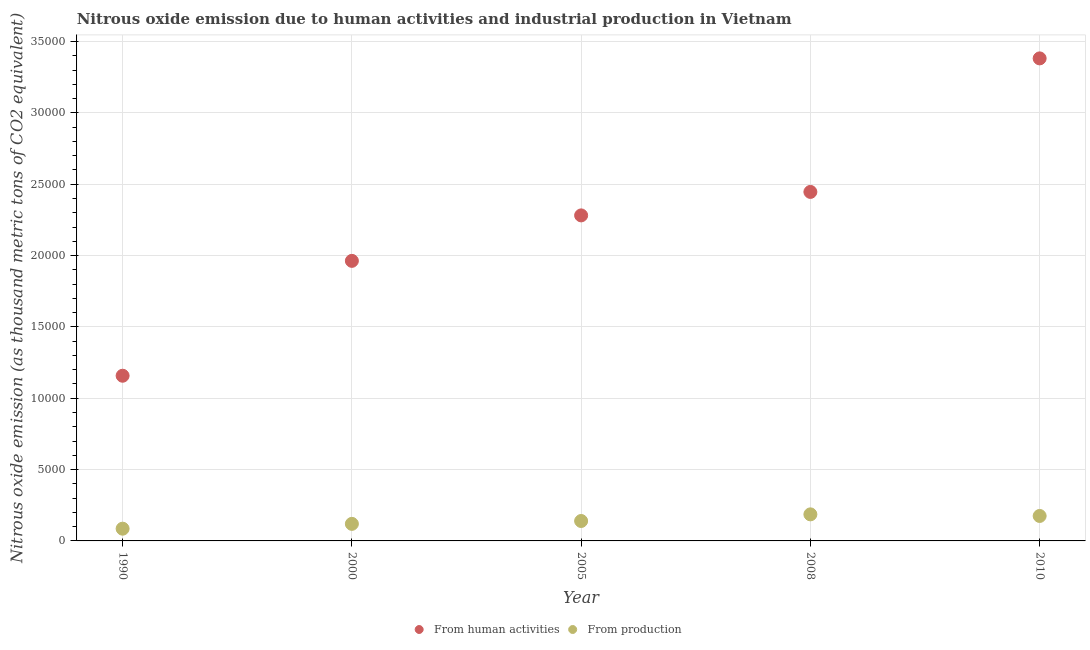How many different coloured dotlines are there?
Keep it short and to the point. 2. What is the amount of emissions generated from industries in 2005?
Provide a short and direct response. 1396.4. Across all years, what is the maximum amount of emissions generated from industries?
Make the answer very short. 1861.6. Across all years, what is the minimum amount of emissions from human activities?
Provide a short and direct response. 1.16e+04. What is the total amount of emissions generated from industries in the graph?
Ensure brevity in your answer.  7060.1. What is the difference between the amount of emissions generated from industries in 1990 and that in 2008?
Ensure brevity in your answer.  -1004.2. What is the difference between the amount of emissions generated from industries in 2000 and the amount of emissions from human activities in 2005?
Give a very brief answer. -2.16e+04. What is the average amount of emissions generated from industries per year?
Offer a very short reply. 1412.02. In the year 2000, what is the difference between the amount of emissions from human activities and amount of emissions generated from industries?
Give a very brief answer. 1.84e+04. What is the ratio of the amount of emissions generated from industries in 1990 to that in 2010?
Ensure brevity in your answer.  0.49. Is the amount of emissions from human activities in 2005 less than that in 2010?
Ensure brevity in your answer.  Yes. Is the difference between the amount of emissions generated from industries in 2000 and 2010 greater than the difference between the amount of emissions from human activities in 2000 and 2010?
Your answer should be very brief. Yes. What is the difference between the highest and the second highest amount of emissions from human activities?
Keep it short and to the point. 9358.4. What is the difference between the highest and the lowest amount of emissions from human activities?
Provide a succinct answer. 2.22e+04. Does the amount of emissions from human activities monotonically increase over the years?
Give a very brief answer. Yes. Is the amount of emissions from human activities strictly greater than the amount of emissions generated from industries over the years?
Ensure brevity in your answer.  Yes. How many years are there in the graph?
Provide a short and direct response. 5. Are the values on the major ticks of Y-axis written in scientific E-notation?
Offer a very short reply. No. Does the graph contain any zero values?
Keep it short and to the point. No. Where does the legend appear in the graph?
Make the answer very short. Bottom center. How are the legend labels stacked?
Offer a terse response. Horizontal. What is the title of the graph?
Your answer should be compact. Nitrous oxide emission due to human activities and industrial production in Vietnam. Does "DAC donors" appear as one of the legend labels in the graph?
Ensure brevity in your answer.  No. What is the label or title of the X-axis?
Make the answer very short. Year. What is the label or title of the Y-axis?
Your answer should be compact. Nitrous oxide emission (as thousand metric tons of CO2 equivalent). What is the Nitrous oxide emission (as thousand metric tons of CO2 equivalent) in From human activities in 1990?
Ensure brevity in your answer.  1.16e+04. What is the Nitrous oxide emission (as thousand metric tons of CO2 equivalent) of From production in 1990?
Keep it short and to the point. 857.4. What is the Nitrous oxide emission (as thousand metric tons of CO2 equivalent) in From human activities in 2000?
Provide a short and direct response. 1.96e+04. What is the Nitrous oxide emission (as thousand metric tons of CO2 equivalent) in From production in 2000?
Offer a very short reply. 1195.6. What is the Nitrous oxide emission (as thousand metric tons of CO2 equivalent) of From human activities in 2005?
Keep it short and to the point. 2.28e+04. What is the Nitrous oxide emission (as thousand metric tons of CO2 equivalent) of From production in 2005?
Provide a succinct answer. 1396.4. What is the Nitrous oxide emission (as thousand metric tons of CO2 equivalent) of From human activities in 2008?
Your answer should be compact. 2.45e+04. What is the Nitrous oxide emission (as thousand metric tons of CO2 equivalent) of From production in 2008?
Ensure brevity in your answer.  1861.6. What is the Nitrous oxide emission (as thousand metric tons of CO2 equivalent) in From human activities in 2010?
Keep it short and to the point. 3.38e+04. What is the Nitrous oxide emission (as thousand metric tons of CO2 equivalent) of From production in 2010?
Make the answer very short. 1749.1. Across all years, what is the maximum Nitrous oxide emission (as thousand metric tons of CO2 equivalent) in From human activities?
Your answer should be very brief. 3.38e+04. Across all years, what is the maximum Nitrous oxide emission (as thousand metric tons of CO2 equivalent) of From production?
Provide a short and direct response. 1861.6. Across all years, what is the minimum Nitrous oxide emission (as thousand metric tons of CO2 equivalent) in From human activities?
Offer a very short reply. 1.16e+04. Across all years, what is the minimum Nitrous oxide emission (as thousand metric tons of CO2 equivalent) in From production?
Ensure brevity in your answer.  857.4. What is the total Nitrous oxide emission (as thousand metric tons of CO2 equivalent) in From human activities in the graph?
Keep it short and to the point. 1.12e+05. What is the total Nitrous oxide emission (as thousand metric tons of CO2 equivalent) in From production in the graph?
Offer a terse response. 7060.1. What is the difference between the Nitrous oxide emission (as thousand metric tons of CO2 equivalent) of From human activities in 1990 and that in 2000?
Your answer should be compact. -8050.5. What is the difference between the Nitrous oxide emission (as thousand metric tons of CO2 equivalent) of From production in 1990 and that in 2000?
Keep it short and to the point. -338.2. What is the difference between the Nitrous oxide emission (as thousand metric tons of CO2 equivalent) in From human activities in 1990 and that in 2005?
Give a very brief answer. -1.12e+04. What is the difference between the Nitrous oxide emission (as thousand metric tons of CO2 equivalent) of From production in 1990 and that in 2005?
Your response must be concise. -539. What is the difference between the Nitrous oxide emission (as thousand metric tons of CO2 equivalent) in From human activities in 1990 and that in 2008?
Your answer should be very brief. -1.29e+04. What is the difference between the Nitrous oxide emission (as thousand metric tons of CO2 equivalent) of From production in 1990 and that in 2008?
Offer a very short reply. -1004.2. What is the difference between the Nitrous oxide emission (as thousand metric tons of CO2 equivalent) in From human activities in 1990 and that in 2010?
Your answer should be compact. -2.22e+04. What is the difference between the Nitrous oxide emission (as thousand metric tons of CO2 equivalent) of From production in 1990 and that in 2010?
Keep it short and to the point. -891.7. What is the difference between the Nitrous oxide emission (as thousand metric tons of CO2 equivalent) in From human activities in 2000 and that in 2005?
Provide a short and direct response. -3186.8. What is the difference between the Nitrous oxide emission (as thousand metric tons of CO2 equivalent) of From production in 2000 and that in 2005?
Ensure brevity in your answer.  -200.8. What is the difference between the Nitrous oxide emission (as thousand metric tons of CO2 equivalent) of From human activities in 2000 and that in 2008?
Your answer should be very brief. -4832.2. What is the difference between the Nitrous oxide emission (as thousand metric tons of CO2 equivalent) in From production in 2000 and that in 2008?
Your answer should be compact. -666. What is the difference between the Nitrous oxide emission (as thousand metric tons of CO2 equivalent) of From human activities in 2000 and that in 2010?
Keep it short and to the point. -1.42e+04. What is the difference between the Nitrous oxide emission (as thousand metric tons of CO2 equivalent) of From production in 2000 and that in 2010?
Offer a terse response. -553.5. What is the difference between the Nitrous oxide emission (as thousand metric tons of CO2 equivalent) in From human activities in 2005 and that in 2008?
Provide a short and direct response. -1645.4. What is the difference between the Nitrous oxide emission (as thousand metric tons of CO2 equivalent) of From production in 2005 and that in 2008?
Offer a very short reply. -465.2. What is the difference between the Nitrous oxide emission (as thousand metric tons of CO2 equivalent) in From human activities in 2005 and that in 2010?
Your answer should be very brief. -1.10e+04. What is the difference between the Nitrous oxide emission (as thousand metric tons of CO2 equivalent) in From production in 2005 and that in 2010?
Ensure brevity in your answer.  -352.7. What is the difference between the Nitrous oxide emission (as thousand metric tons of CO2 equivalent) of From human activities in 2008 and that in 2010?
Offer a terse response. -9358.4. What is the difference between the Nitrous oxide emission (as thousand metric tons of CO2 equivalent) in From production in 2008 and that in 2010?
Offer a very short reply. 112.5. What is the difference between the Nitrous oxide emission (as thousand metric tons of CO2 equivalent) of From human activities in 1990 and the Nitrous oxide emission (as thousand metric tons of CO2 equivalent) of From production in 2000?
Your answer should be compact. 1.04e+04. What is the difference between the Nitrous oxide emission (as thousand metric tons of CO2 equivalent) in From human activities in 1990 and the Nitrous oxide emission (as thousand metric tons of CO2 equivalent) in From production in 2005?
Ensure brevity in your answer.  1.02e+04. What is the difference between the Nitrous oxide emission (as thousand metric tons of CO2 equivalent) in From human activities in 1990 and the Nitrous oxide emission (as thousand metric tons of CO2 equivalent) in From production in 2008?
Your answer should be compact. 9715.2. What is the difference between the Nitrous oxide emission (as thousand metric tons of CO2 equivalent) in From human activities in 1990 and the Nitrous oxide emission (as thousand metric tons of CO2 equivalent) in From production in 2010?
Make the answer very short. 9827.7. What is the difference between the Nitrous oxide emission (as thousand metric tons of CO2 equivalent) of From human activities in 2000 and the Nitrous oxide emission (as thousand metric tons of CO2 equivalent) of From production in 2005?
Provide a succinct answer. 1.82e+04. What is the difference between the Nitrous oxide emission (as thousand metric tons of CO2 equivalent) of From human activities in 2000 and the Nitrous oxide emission (as thousand metric tons of CO2 equivalent) of From production in 2008?
Keep it short and to the point. 1.78e+04. What is the difference between the Nitrous oxide emission (as thousand metric tons of CO2 equivalent) in From human activities in 2000 and the Nitrous oxide emission (as thousand metric tons of CO2 equivalent) in From production in 2010?
Your answer should be compact. 1.79e+04. What is the difference between the Nitrous oxide emission (as thousand metric tons of CO2 equivalent) of From human activities in 2005 and the Nitrous oxide emission (as thousand metric tons of CO2 equivalent) of From production in 2008?
Give a very brief answer. 2.10e+04. What is the difference between the Nitrous oxide emission (as thousand metric tons of CO2 equivalent) of From human activities in 2005 and the Nitrous oxide emission (as thousand metric tons of CO2 equivalent) of From production in 2010?
Offer a terse response. 2.11e+04. What is the difference between the Nitrous oxide emission (as thousand metric tons of CO2 equivalent) in From human activities in 2008 and the Nitrous oxide emission (as thousand metric tons of CO2 equivalent) in From production in 2010?
Keep it short and to the point. 2.27e+04. What is the average Nitrous oxide emission (as thousand metric tons of CO2 equivalent) in From human activities per year?
Your answer should be compact. 2.25e+04. What is the average Nitrous oxide emission (as thousand metric tons of CO2 equivalent) of From production per year?
Keep it short and to the point. 1412.02. In the year 1990, what is the difference between the Nitrous oxide emission (as thousand metric tons of CO2 equivalent) in From human activities and Nitrous oxide emission (as thousand metric tons of CO2 equivalent) in From production?
Ensure brevity in your answer.  1.07e+04. In the year 2000, what is the difference between the Nitrous oxide emission (as thousand metric tons of CO2 equivalent) of From human activities and Nitrous oxide emission (as thousand metric tons of CO2 equivalent) of From production?
Give a very brief answer. 1.84e+04. In the year 2005, what is the difference between the Nitrous oxide emission (as thousand metric tons of CO2 equivalent) in From human activities and Nitrous oxide emission (as thousand metric tons of CO2 equivalent) in From production?
Provide a short and direct response. 2.14e+04. In the year 2008, what is the difference between the Nitrous oxide emission (as thousand metric tons of CO2 equivalent) of From human activities and Nitrous oxide emission (as thousand metric tons of CO2 equivalent) of From production?
Your response must be concise. 2.26e+04. In the year 2010, what is the difference between the Nitrous oxide emission (as thousand metric tons of CO2 equivalent) of From human activities and Nitrous oxide emission (as thousand metric tons of CO2 equivalent) of From production?
Make the answer very short. 3.21e+04. What is the ratio of the Nitrous oxide emission (as thousand metric tons of CO2 equivalent) of From human activities in 1990 to that in 2000?
Give a very brief answer. 0.59. What is the ratio of the Nitrous oxide emission (as thousand metric tons of CO2 equivalent) of From production in 1990 to that in 2000?
Give a very brief answer. 0.72. What is the ratio of the Nitrous oxide emission (as thousand metric tons of CO2 equivalent) in From human activities in 1990 to that in 2005?
Offer a very short reply. 0.51. What is the ratio of the Nitrous oxide emission (as thousand metric tons of CO2 equivalent) in From production in 1990 to that in 2005?
Give a very brief answer. 0.61. What is the ratio of the Nitrous oxide emission (as thousand metric tons of CO2 equivalent) of From human activities in 1990 to that in 2008?
Give a very brief answer. 0.47. What is the ratio of the Nitrous oxide emission (as thousand metric tons of CO2 equivalent) in From production in 1990 to that in 2008?
Keep it short and to the point. 0.46. What is the ratio of the Nitrous oxide emission (as thousand metric tons of CO2 equivalent) in From human activities in 1990 to that in 2010?
Provide a short and direct response. 0.34. What is the ratio of the Nitrous oxide emission (as thousand metric tons of CO2 equivalent) in From production in 1990 to that in 2010?
Offer a very short reply. 0.49. What is the ratio of the Nitrous oxide emission (as thousand metric tons of CO2 equivalent) of From human activities in 2000 to that in 2005?
Give a very brief answer. 0.86. What is the ratio of the Nitrous oxide emission (as thousand metric tons of CO2 equivalent) in From production in 2000 to that in 2005?
Provide a short and direct response. 0.86. What is the ratio of the Nitrous oxide emission (as thousand metric tons of CO2 equivalent) of From human activities in 2000 to that in 2008?
Ensure brevity in your answer.  0.8. What is the ratio of the Nitrous oxide emission (as thousand metric tons of CO2 equivalent) of From production in 2000 to that in 2008?
Give a very brief answer. 0.64. What is the ratio of the Nitrous oxide emission (as thousand metric tons of CO2 equivalent) of From human activities in 2000 to that in 2010?
Your answer should be very brief. 0.58. What is the ratio of the Nitrous oxide emission (as thousand metric tons of CO2 equivalent) in From production in 2000 to that in 2010?
Your response must be concise. 0.68. What is the ratio of the Nitrous oxide emission (as thousand metric tons of CO2 equivalent) in From human activities in 2005 to that in 2008?
Your answer should be compact. 0.93. What is the ratio of the Nitrous oxide emission (as thousand metric tons of CO2 equivalent) of From production in 2005 to that in 2008?
Your response must be concise. 0.75. What is the ratio of the Nitrous oxide emission (as thousand metric tons of CO2 equivalent) of From human activities in 2005 to that in 2010?
Offer a very short reply. 0.67. What is the ratio of the Nitrous oxide emission (as thousand metric tons of CO2 equivalent) of From production in 2005 to that in 2010?
Your answer should be compact. 0.8. What is the ratio of the Nitrous oxide emission (as thousand metric tons of CO2 equivalent) of From human activities in 2008 to that in 2010?
Ensure brevity in your answer.  0.72. What is the ratio of the Nitrous oxide emission (as thousand metric tons of CO2 equivalent) in From production in 2008 to that in 2010?
Make the answer very short. 1.06. What is the difference between the highest and the second highest Nitrous oxide emission (as thousand metric tons of CO2 equivalent) in From human activities?
Offer a very short reply. 9358.4. What is the difference between the highest and the second highest Nitrous oxide emission (as thousand metric tons of CO2 equivalent) in From production?
Make the answer very short. 112.5. What is the difference between the highest and the lowest Nitrous oxide emission (as thousand metric tons of CO2 equivalent) of From human activities?
Your answer should be very brief. 2.22e+04. What is the difference between the highest and the lowest Nitrous oxide emission (as thousand metric tons of CO2 equivalent) of From production?
Keep it short and to the point. 1004.2. 